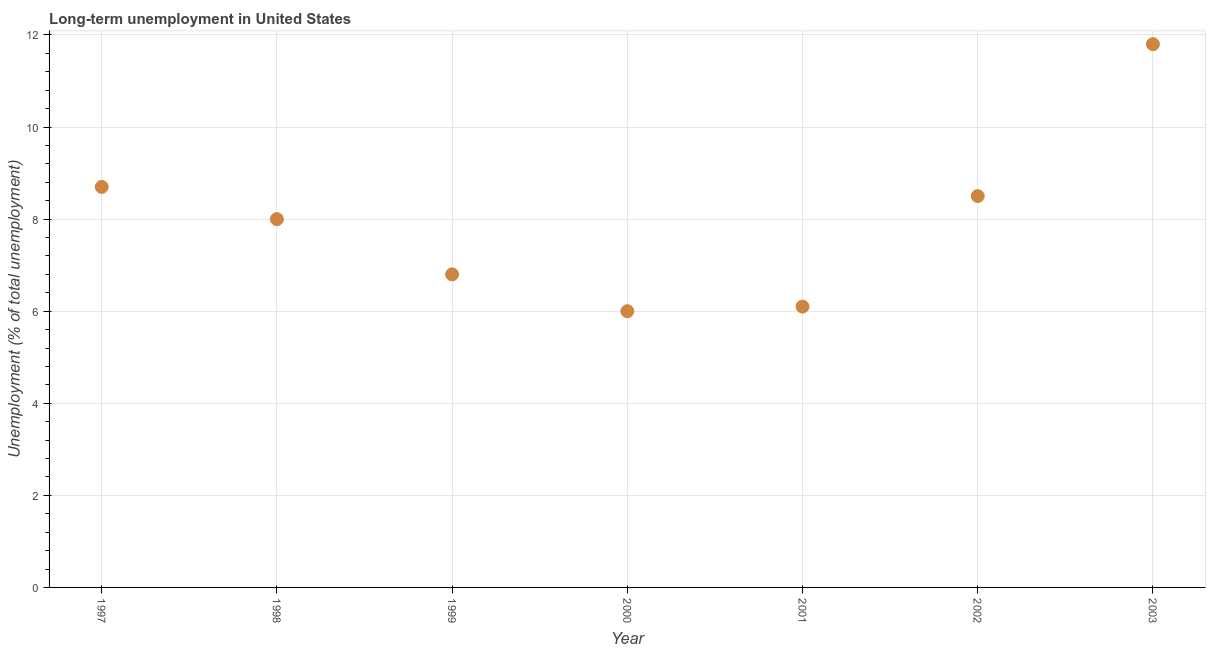Across all years, what is the maximum long-term unemployment?
Your answer should be very brief. 11.8. In which year was the long-term unemployment minimum?
Give a very brief answer. 2000. What is the sum of the long-term unemployment?
Provide a short and direct response. 55.9. What is the difference between the long-term unemployment in 2000 and 2002?
Provide a short and direct response. -2.5. What is the average long-term unemployment per year?
Make the answer very short. 7.99. In how many years, is the long-term unemployment greater than 7.6 %?
Provide a succinct answer. 4. Do a majority of the years between 2003 and 2002 (inclusive) have long-term unemployment greater than 5.6 %?
Your answer should be very brief. No. What is the ratio of the long-term unemployment in 1998 to that in 1999?
Your answer should be compact. 1.18. Is the long-term unemployment in 2002 less than that in 2003?
Your answer should be compact. Yes. What is the difference between the highest and the second highest long-term unemployment?
Give a very brief answer. 3.1. Is the sum of the long-term unemployment in 1997 and 1998 greater than the maximum long-term unemployment across all years?
Provide a short and direct response. Yes. What is the difference between the highest and the lowest long-term unemployment?
Offer a terse response. 5.8. In how many years, is the long-term unemployment greater than the average long-term unemployment taken over all years?
Offer a terse response. 4. Does the long-term unemployment monotonically increase over the years?
Your response must be concise. No. Does the graph contain any zero values?
Offer a terse response. No. What is the title of the graph?
Give a very brief answer. Long-term unemployment in United States. What is the label or title of the Y-axis?
Your answer should be compact. Unemployment (% of total unemployment). What is the Unemployment (% of total unemployment) in 1997?
Your response must be concise. 8.7. What is the Unemployment (% of total unemployment) in 1999?
Your answer should be compact. 6.8. What is the Unemployment (% of total unemployment) in 2000?
Provide a succinct answer. 6. What is the Unemployment (% of total unemployment) in 2001?
Your response must be concise. 6.1. What is the Unemployment (% of total unemployment) in 2002?
Keep it short and to the point. 8.5. What is the Unemployment (% of total unemployment) in 2003?
Provide a short and direct response. 11.8. What is the difference between the Unemployment (% of total unemployment) in 1997 and 2001?
Provide a short and direct response. 2.6. What is the difference between the Unemployment (% of total unemployment) in 1998 and 1999?
Ensure brevity in your answer.  1.2. What is the difference between the Unemployment (% of total unemployment) in 1998 and 2000?
Give a very brief answer. 2. What is the difference between the Unemployment (% of total unemployment) in 1998 and 2002?
Offer a terse response. -0.5. What is the difference between the Unemployment (% of total unemployment) in 1999 and 2000?
Make the answer very short. 0.8. What is the difference between the Unemployment (% of total unemployment) in 1999 and 2002?
Your answer should be compact. -1.7. What is the difference between the Unemployment (% of total unemployment) in 2000 and 2002?
Your answer should be compact. -2.5. What is the difference between the Unemployment (% of total unemployment) in 2001 and 2002?
Offer a very short reply. -2.4. What is the difference between the Unemployment (% of total unemployment) in 2001 and 2003?
Provide a short and direct response. -5.7. What is the difference between the Unemployment (% of total unemployment) in 2002 and 2003?
Your answer should be very brief. -3.3. What is the ratio of the Unemployment (% of total unemployment) in 1997 to that in 1998?
Your answer should be compact. 1.09. What is the ratio of the Unemployment (% of total unemployment) in 1997 to that in 1999?
Give a very brief answer. 1.28. What is the ratio of the Unemployment (% of total unemployment) in 1997 to that in 2000?
Your answer should be compact. 1.45. What is the ratio of the Unemployment (% of total unemployment) in 1997 to that in 2001?
Offer a terse response. 1.43. What is the ratio of the Unemployment (% of total unemployment) in 1997 to that in 2002?
Give a very brief answer. 1.02. What is the ratio of the Unemployment (% of total unemployment) in 1997 to that in 2003?
Offer a terse response. 0.74. What is the ratio of the Unemployment (% of total unemployment) in 1998 to that in 1999?
Your answer should be very brief. 1.18. What is the ratio of the Unemployment (% of total unemployment) in 1998 to that in 2000?
Offer a terse response. 1.33. What is the ratio of the Unemployment (% of total unemployment) in 1998 to that in 2001?
Offer a terse response. 1.31. What is the ratio of the Unemployment (% of total unemployment) in 1998 to that in 2002?
Your answer should be very brief. 0.94. What is the ratio of the Unemployment (% of total unemployment) in 1998 to that in 2003?
Provide a short and direct response. 0.68. What is the ratio of the Unemployment (% of total unemployment) in 1999 to that in 2000?
Provide a succinct answer. 1.13. What is the ratio of the Unemployment (% of total unemployment) in 1999 to that in 2001?
Your answer should be compact. 1.11. What is the ratio of the Unemployment (% of total unemployment) in 1999 to that in 2003?
Offer a very short reply. 0.58. What is the ratio of the Unemployment (% of total unemployment) in 2000 to that in 2001?
Give a very brief answer. 0.98. What is the ratio of the Unemployment (% of total unemployment) in 2000 to that in 2002?
Give a very brief answer. 0.71. What is the ratio of the Unemployment (% of total unemployment) in 2000 to that in 2003?
Make the answer very short. 0.51. What is the ratio of the Unemployment (% of total unemployment) in 2001 to that in 2002?
Your answer should be compact. 0.72. What is the ratio of the Unemployment (% of total unemployment) in 2001 to that in 2003?
Your answer should be compact. 0.52. What is the ratio of the Unemployment (% of total unemployment) in 2002 to that in 2003?
Your answer should be very brief. 0.72. 